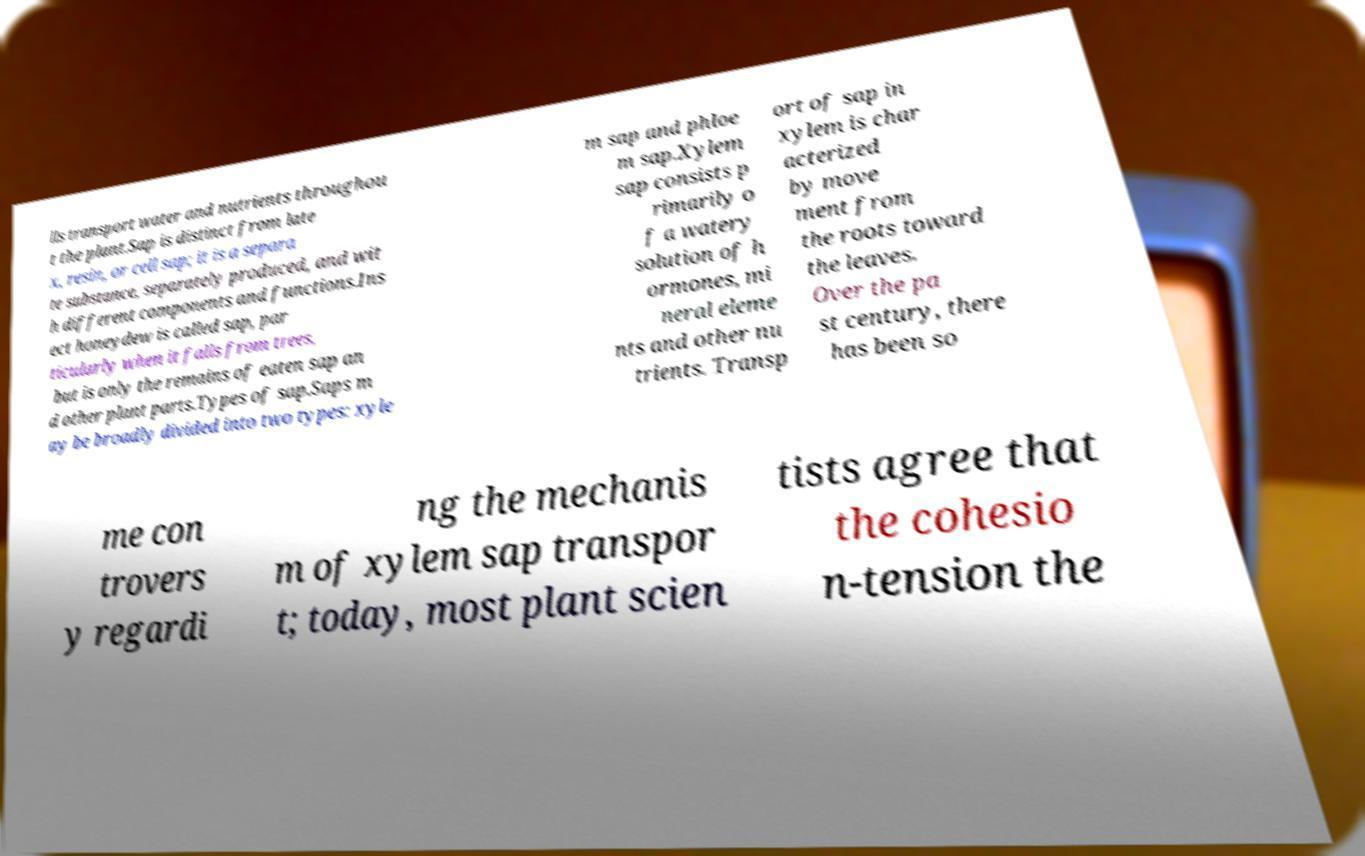Could you assist in decoding the text presented in this image and type it out clearly? lls transport water and nutrients throughou t the plant.Sap is distinct from late x, resin, or cell sap; it is a separa te substance, separately produced, and wit h different components and functions.Ins ect honeydew is called sap, par ticularly when it falls from trees, but is only the remains of eaten sap an d other plant parts.Types of sap.Saps m ay be broadly divided into two types: xyle m sap and phloe m sap.Xylem sap consists p rimarily o f a watery solution of h ormones, mi neral eleme nts and other nu trients. Transp ort of sap in xylem is char acterized by move ment from the roots toward the leaves. Over the pa st century, there has been so me con trovers y regardi ng the mechanis m of xylem sap transpor t; today, most plant scien tists agree that the cohesio n-tension the 